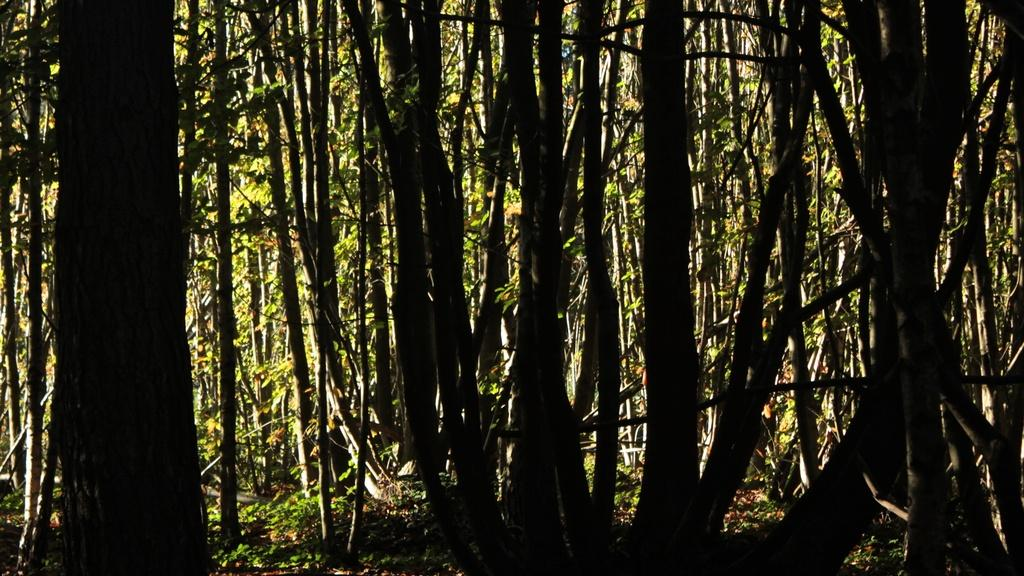What type of vegetation can be seen in the image? There are trees and plants in the image. Can you describe the plants in the image? Unfortunately, the facts provided do not give specific details about the plants in the image. How many trees are visible in the image? The facts provided do not specify the number of trees in the image. How fast do the dinosaurs move in the image? There are no dinosaurs present in the image. What is the wish of the person in the image? The facts provided do not mention any person in the image, so it is impossible to determine their wish. 